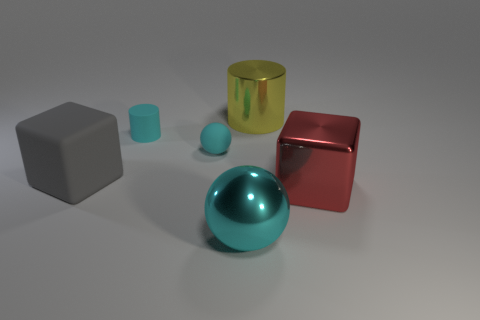Add 4 small cyan matte balls. How many objects exist? 10 Subtract all cyan cylinders. How many cylinders are left? 1 Subtract all spheres. How many objects are left? 4 Subtract 2 cylinders. How many cylinders are left? 0 Subtract all yellow cylinders. Subtract all red spheres. How many cylinders are left? 1 Subtract all large yellow metallic things. Subtract all large green metallic blocks. How many objects are left? 5 Add 5 rubber spheres. How many rubber spheres are left? 6 Add 2 large red spheres. How many large red spheres exist? 2 Subtract 0 cyan cubes. How many objects are left? 6 